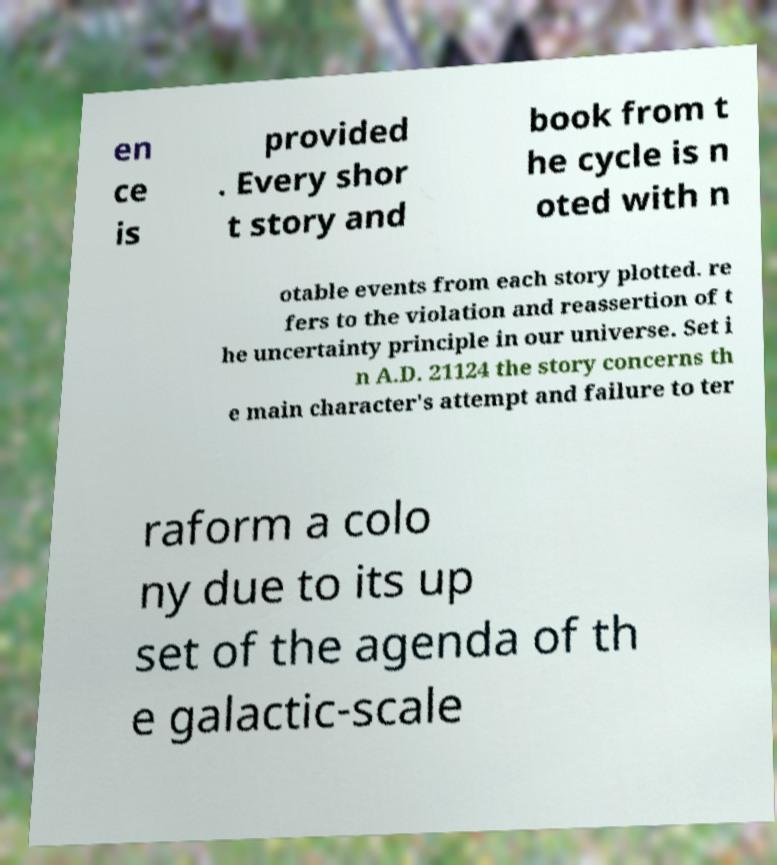Can you accurately transcribe the text from the provided image for me? en ce is provided . Every shor t story and book from t he cycle is n oted with n otable events from each story plotted. re fers to the violation and reassertion of t he uncertainty principle in our universe. Set i n A.D. 21124 the story concerns th e main character's attempt and failure to ter raform a colo ny due to its up set of the agenda of th e galactic-scale 